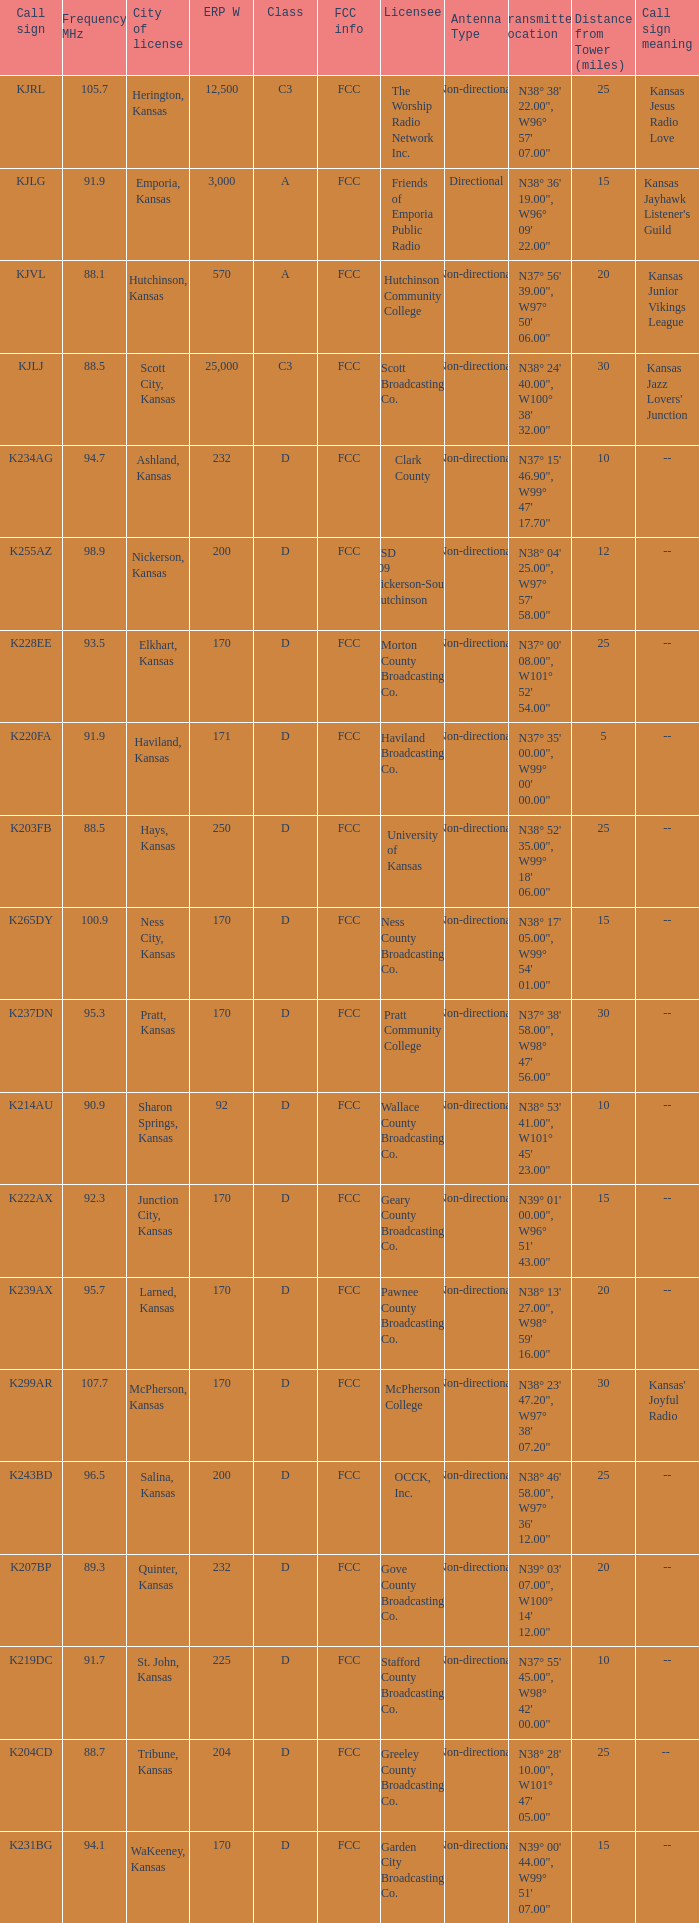Frequency MHz smaller than 95.3, and a Call sign of k234ag is what class? D. 